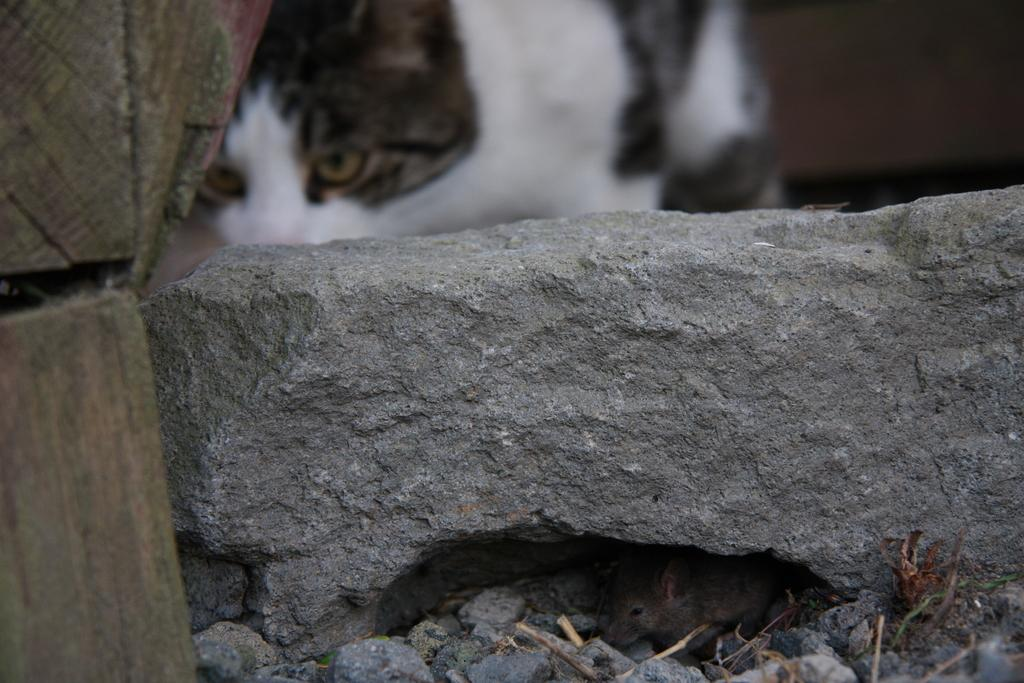What animal is located at the bottom of the image? There is a rat at the bottom of the image. What object is in the middle of the image? There is a stone in the middle of the image. What type of material is used for the planks on the left side of the image? The planks on the left side of the image are made of wood. What animal is located at the top of the image? There is a cat at the top of the image. What type of fan can be seen in the image? There is no fan present in the image. What type of road is visible in the image? There is no road visible in the image. 